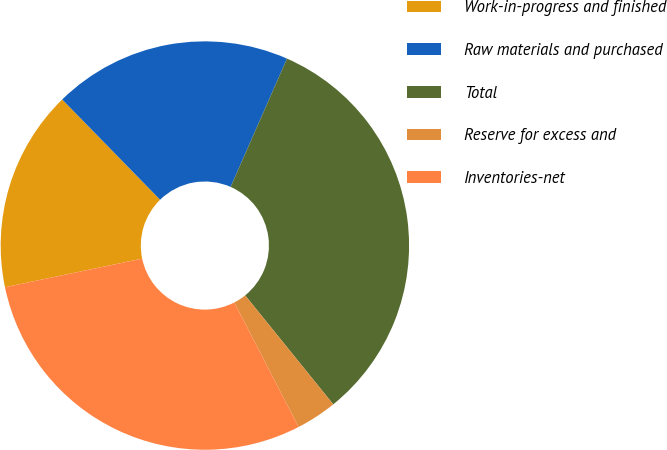<chart> <loc_0><loc_0><loc_500><loc_500><pie_chart><fcel>Work-in-progress and finished<fcel>Raw materials and purchased<fcel>Total<fcel>Reserve for excess and<fcel>Inventories-net<nl><fcel>15.96%<fcel>18.9%<fcel>32.59%<fcel>3.23%<fcel>29.32%<nl></chart> 